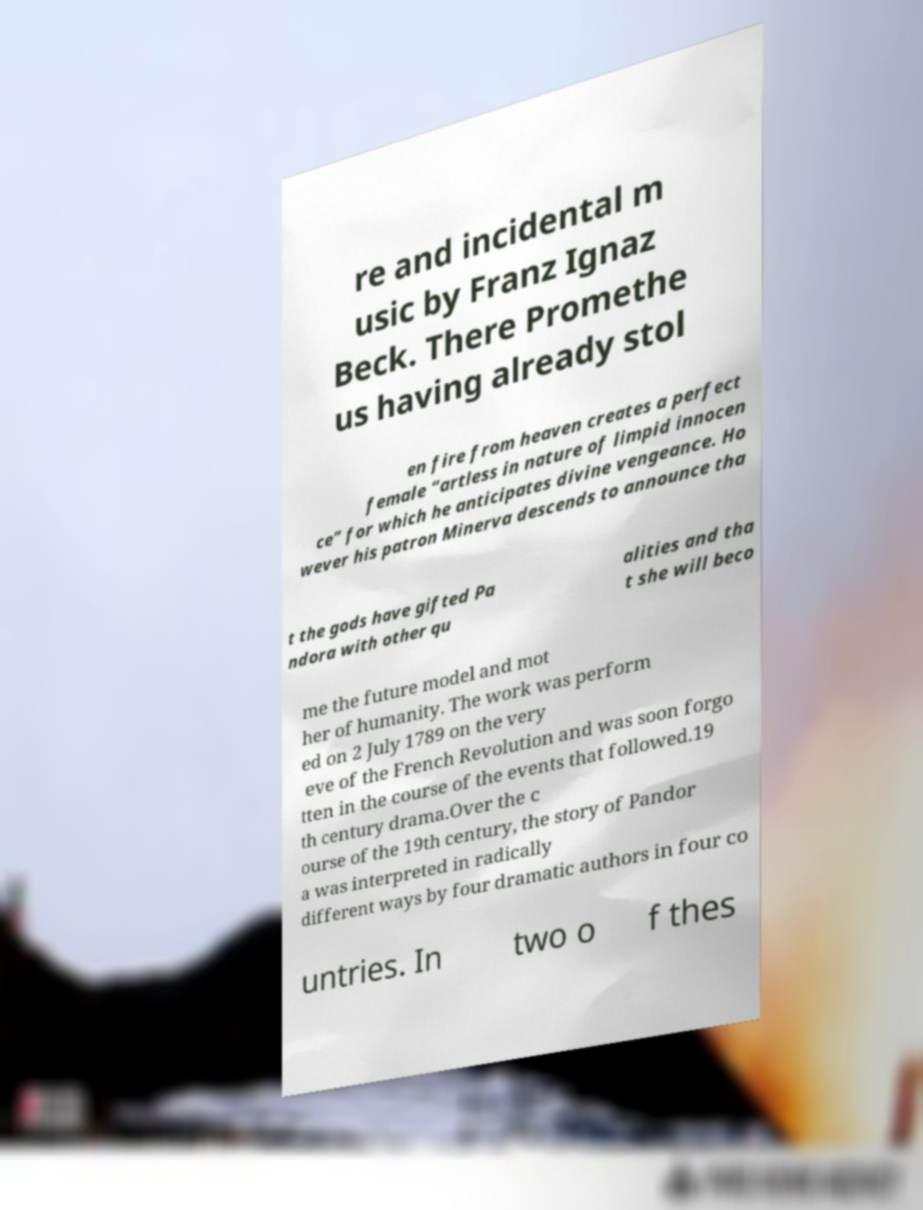Could you assist in decoding the text presented in this image and type it out clearly? re and incidental m usic by Franz Ignaz Beck. There Promethe us having already stol en fire from heaven creates a perfect female “artless in nature of limpid innocen ce” for which he anticipates divine vengeance. Ho wever his patron Minerva descends to announce tha t the gods have gifted Pa ndora with other qu alities and tha t she will beco me the future model and mot her of humanity. The work was perform ed on 2 July 1789 on the very eve of the French Revolution and was soon forgo tten in the course of the events that followed.19 th century drama.Over the c ourse of the 19th century, the story of Pandor a was interpreted in radically different ways by four dramatic authors in four co untries. In two o f thes 